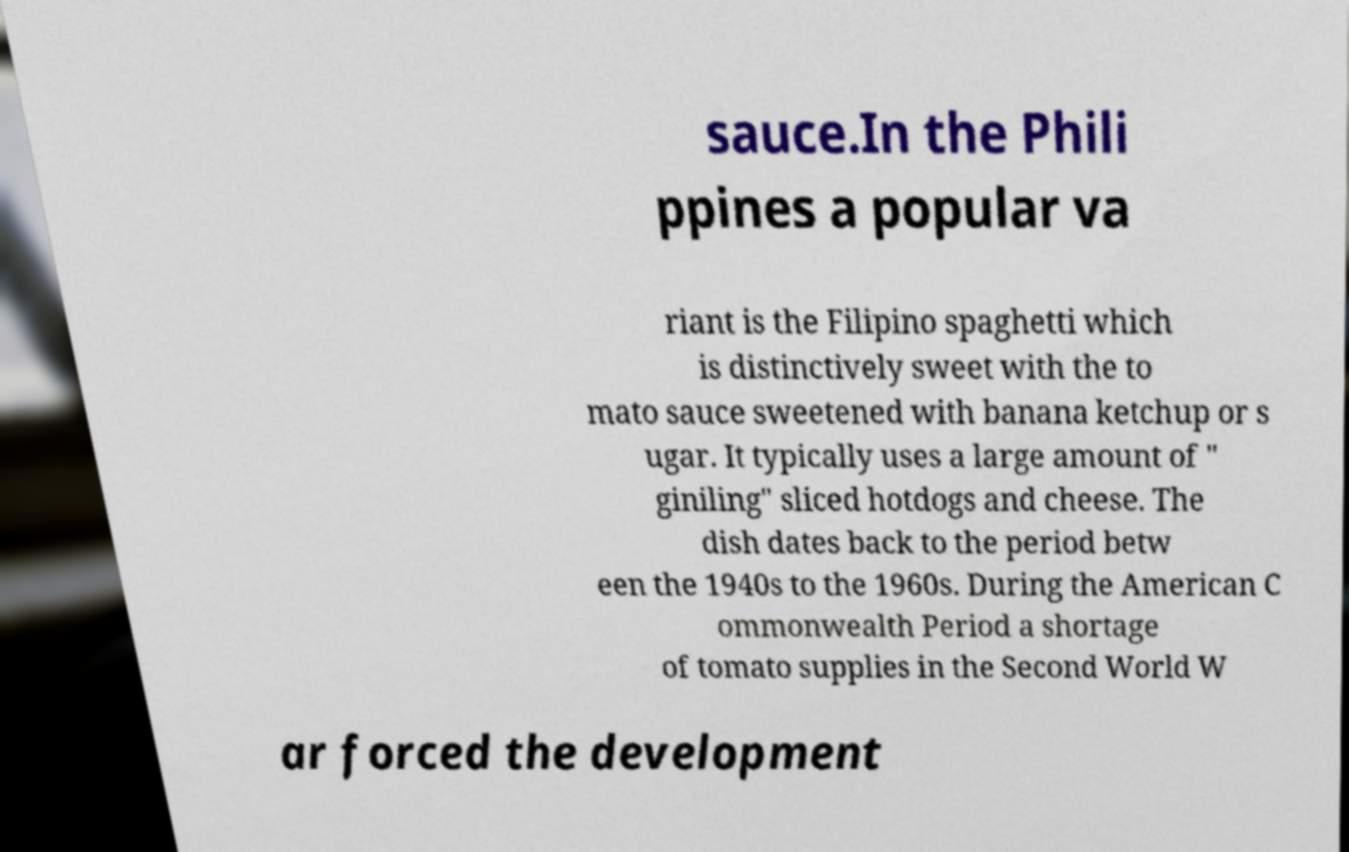There's text embedded in this image that I need extracted. Can you transcribe it verbatim? sauce.In the Phili ppines a popular va riant is the Filipino spaghetti which is distinctively sweet with the to mato sauce sweetened with banana ketchup or s ugar. It typically uses a large amount of " giniling" sliced hotdogs and cheese. The dish dates back to the period betw een the 1940s to the 1960s. During the American C ommonwealth Period a shortage of tomato supplies in the Second World W ar forced the development 